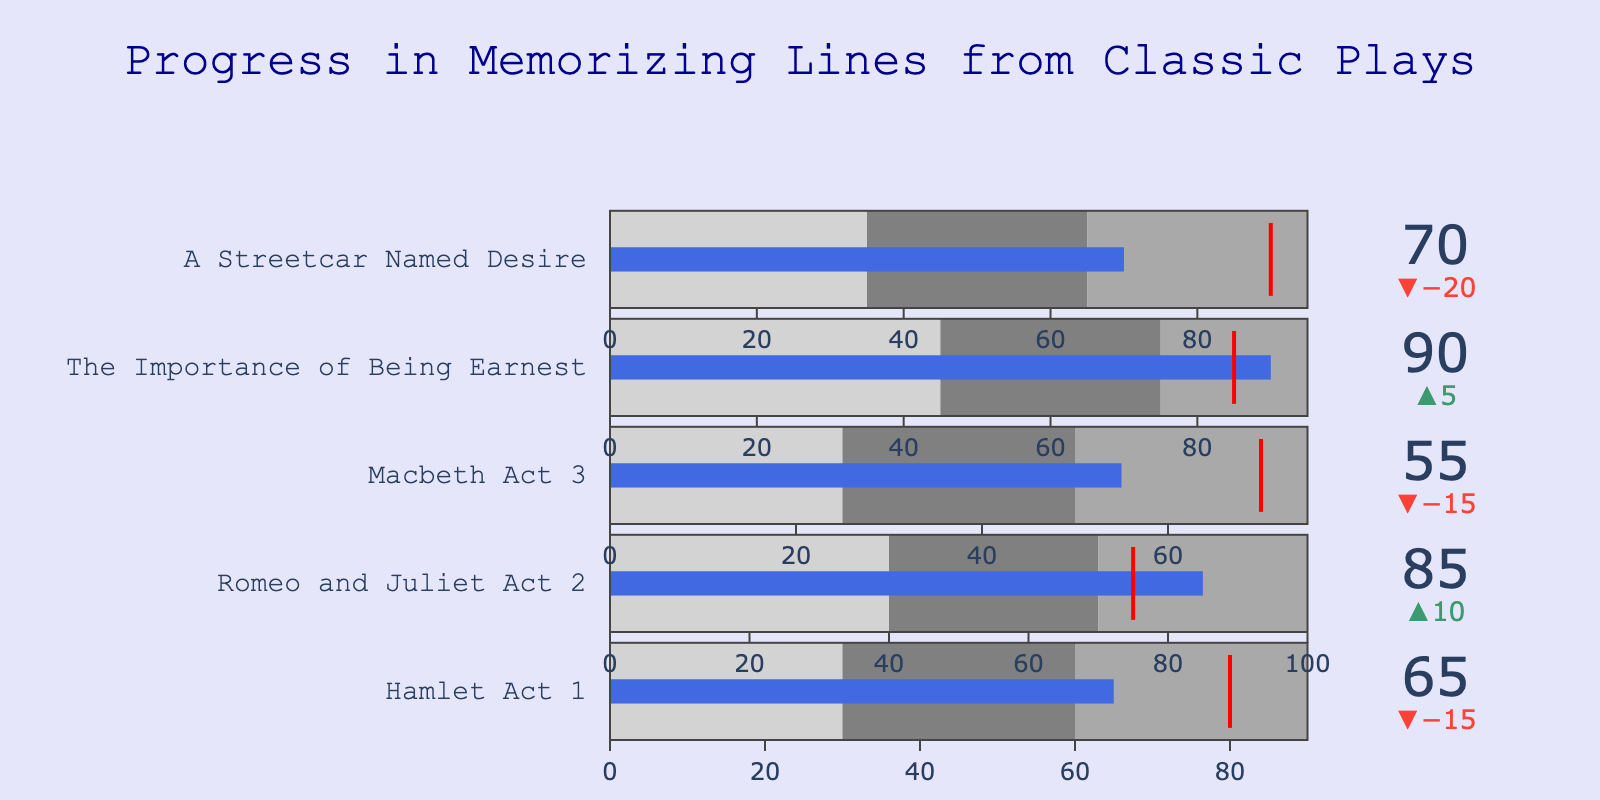What's the title of the figure? The title is displayed prominently at the top of the chart. It reads: "Progress in Memorizing Lines from Classic Plays."
Answer: Progress in Memorizing Lines from Classic Plays How many plays are tracked in the chart? Each bullet chart represents one play, and there are five bullet charts, so five plays are being tracked.
Answer: Five What is the actual progress for "Hamlet Act 1"? The actual progress for "Hamlet Act 1" is indicated by the blue bar on its corresponding bullet chart, which shows 65.
Answer: 65 Which play has the highest actual progress? By comparing the length of the blue bars across all bullet charts, "The Importance of Being Earnest" has the highest actual progress at 90.
Answer: The Importance of Being Earnest Which plays have actual progress above their targets? To determine this, we compare the actual values (blue bars) to the target values (red lines). "Romeo and Juliet Act 2" (actual 85, target 75) and "The Importance of Being Earnest" (actual 90, target 85) have surpassed their targets.
Answer: Romeo and Juliet Act 2, The Importance of Being Earnest What is the delta (difference) between actual and target for "Macbeth Act 3"? The delta is calculated by subtracting the actual value (55) from the target value (70). Therefore, the delta is 70 - 55 = 15.
Answer: 15 Which play's progress falls into the dark gray range (Range 2 to Range 3) the most? By inspecting the dark gray shaded areas on each bullet chart, "Romeo and Juliet Act 2" falls mostly into this range with progress of 85 in a range of 70-100.
Answer: Romeo and Juliet Act 2 For "A Streetcar Named Desire," how far is the actual progress from reaching the target? The actual progress for "A Streetcar Named Desire" is 70, and the target is 90. The difference is 90 - 70 = 20.
Answer: 20 Which play has the smallest difference between actual progress and target? The smallest difference is observed by comparing the deltas. "The Importance of Being Earnest" has a delta of 90 - 85 = 5, which is the smallest.
Answer: The Importance of Being Earnest 